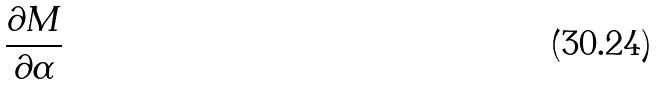Convert formula to latex. <formula><loc_0><loc_0><loc_500><loc_500>\frac { \partial M } { \partial \alpha }</formula> 